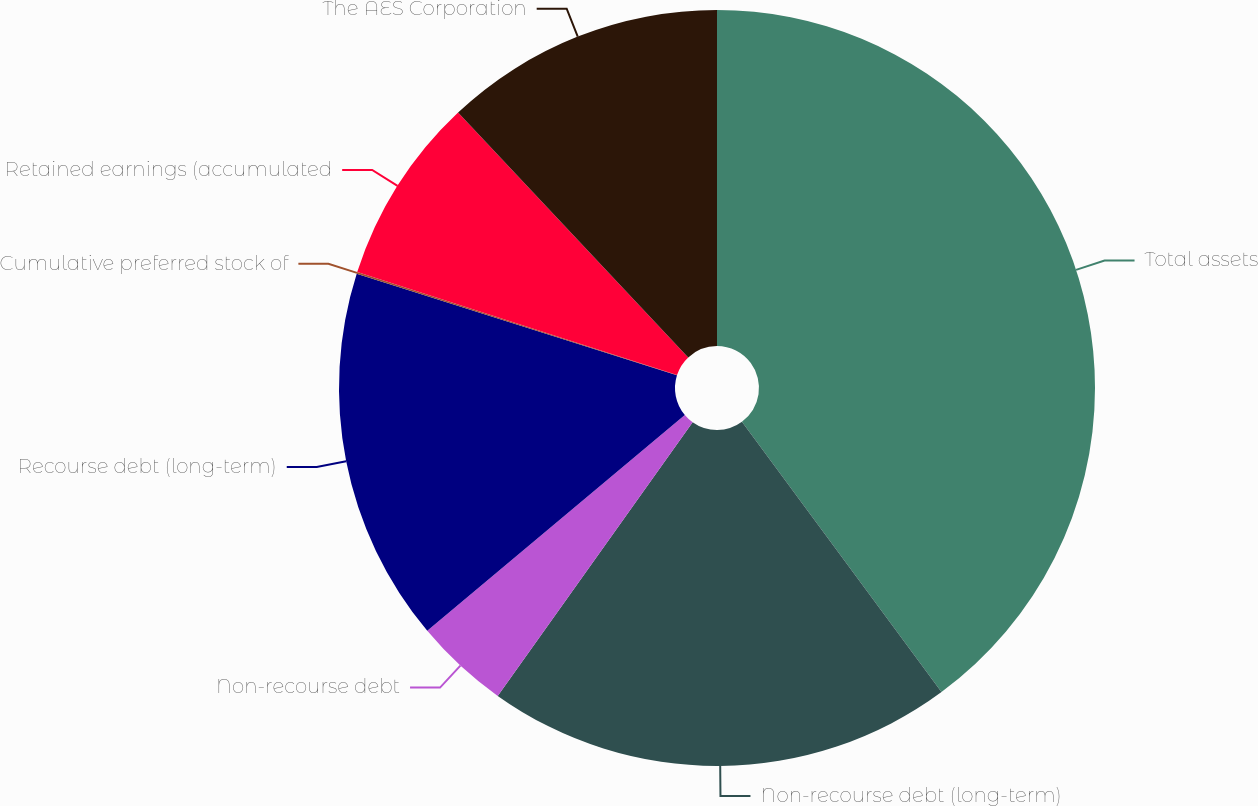Convert chart to OTSL. <chart><loc_0><loc_0><loc_500><loc_500><pie_chart><fcel>Total assets<fcel>Non-recourse debt (long-term)<fcel>Non-recourse debt<fcel>Recourse debt (long-term)<fcel>Cumulative preferred stock of<fcel>Retained earnings (accumulated<fcel>The AES Corporation<nl><fcel>39.88%<fcel>19.97%<fcel>4.05%<fcel>15.99%<fcel>0.07%<fcel>8.03%<fcel>12.01%<nl></chart> 